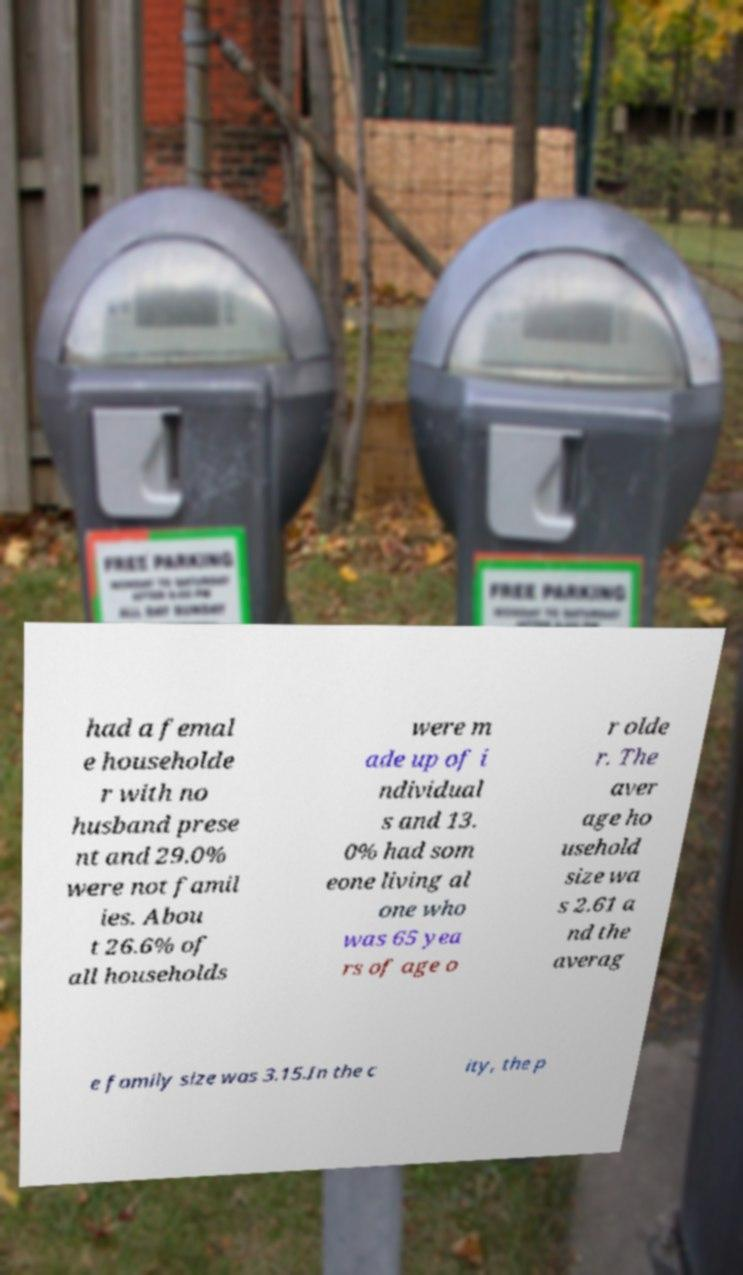Could you extract and type out the text from this image? had a femal e householde r with no husband prese nt and 29.0% were not famil ies. Abou t 26.6% of all households were m ade up of i ndividual s and 13. 0% had som eone living al one who was 65 yea rs of age o r olde r. The aver age ho usehold size wa s 2.61 a nd the averag e family size was 3.15.In the c ity, the p 